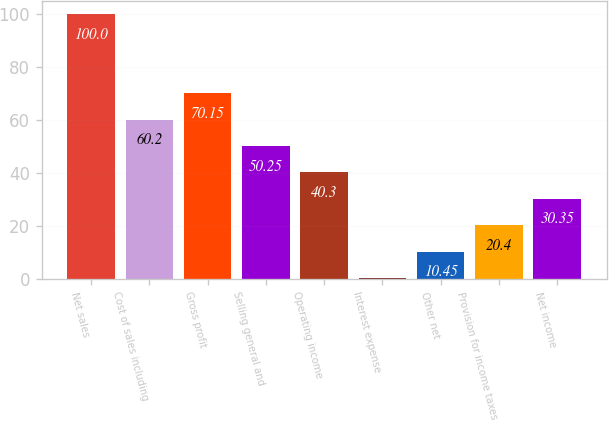<chart> <loc_0><loc_0><loc_500><loc_500><bar_chart><fcel>Net sales<fcel>Cost of sales including<fcel>Gross profit<fcel>Selling general and<fcel>Operating income<fcel>Interest expense<fcel>Other net<fcel>Provision for income taxes<fcel>Net income<nl><fcel>100<fcel>60.2<fcel>70.15<fcel>50.25<fcel>40.3<fcel>0.5<fcel>10.45<fcel>20.4<fcel>30.35<nl></chart> 